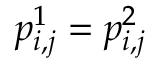<formula> <loc_0><loc_0><loc_500><loc_500>p _ { i , j } ^ { 1 } = p _ { i , j } ^ { 2 }</formula> 